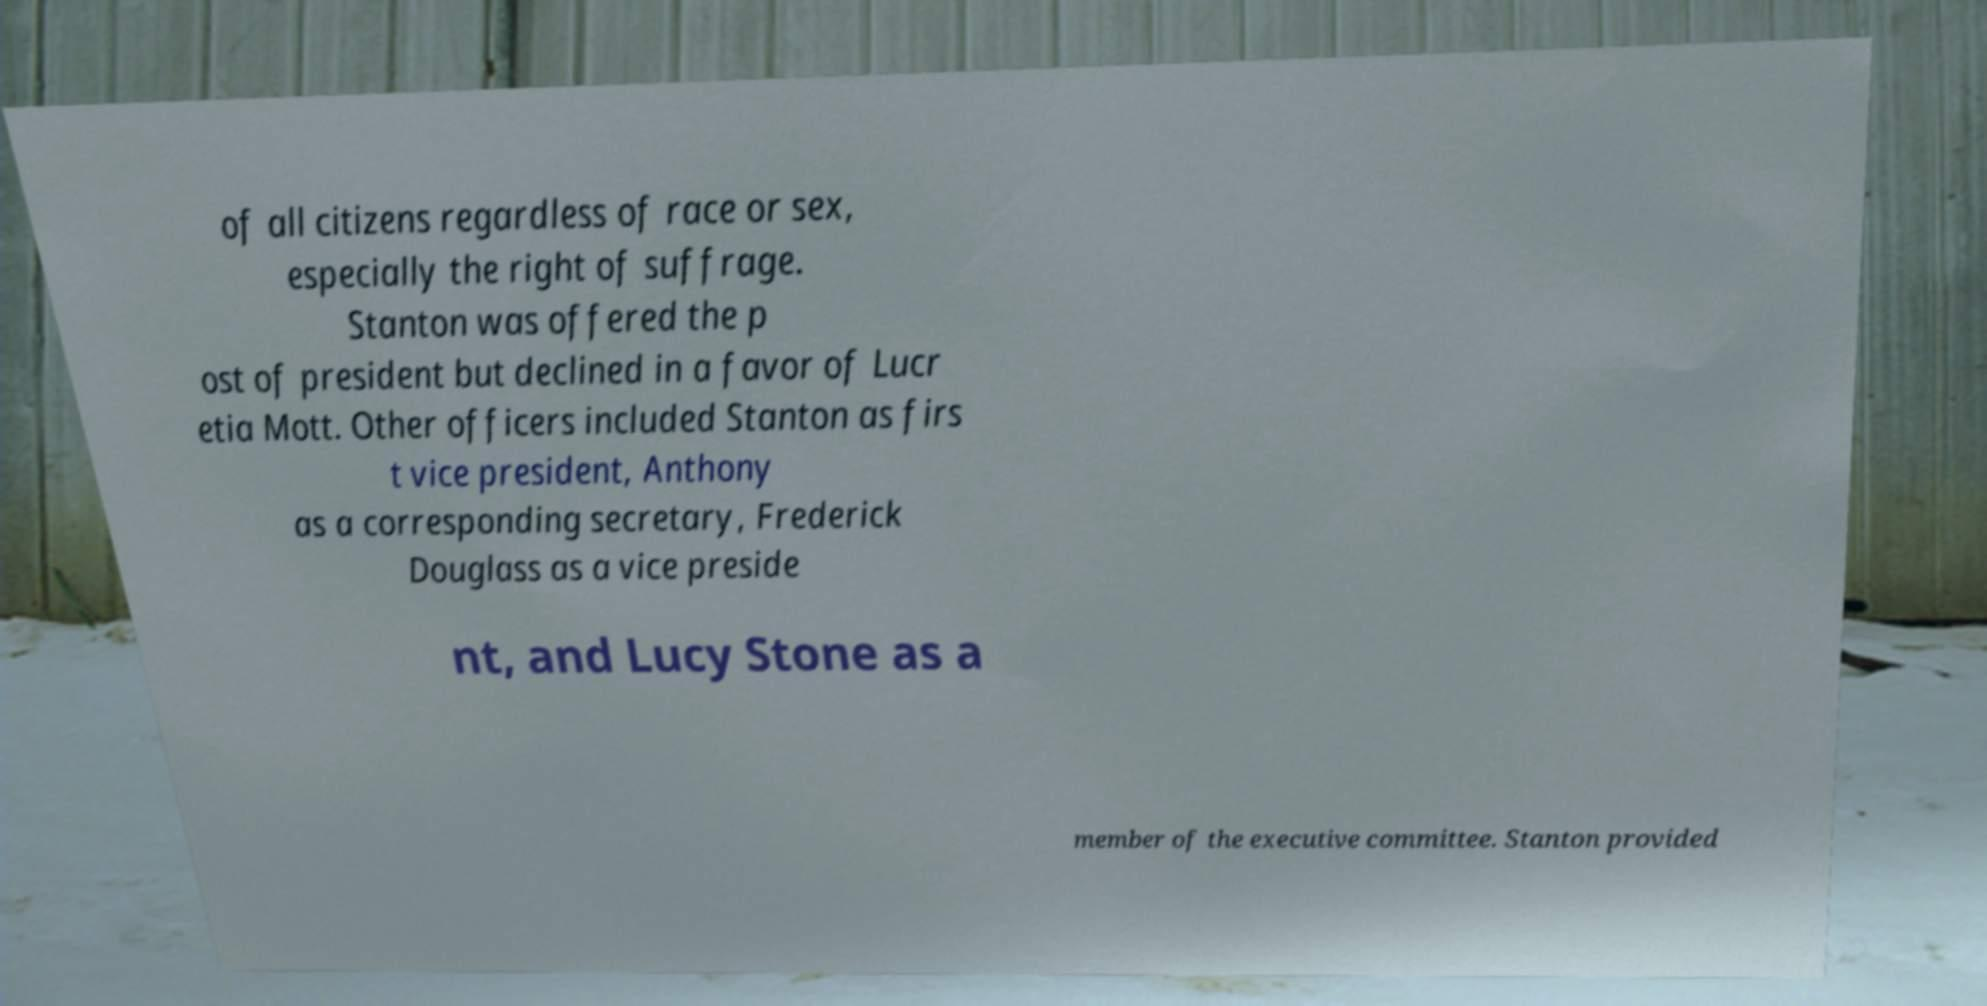There's text embedded in this image that I need extracted. Can you transcribe it verbatim? of all citizens regardless of race or sex, especially the right of suffrage. Stanton was offered the p ost of president but declined in a favor of Lucr etia Mott. Other officers included Stanton as firs t vice president, Anthony as a corresponding secretary, Frederick Douglass as a vice preside nt, and Lucy Stone as a member of the executive committee. Stanton provided 